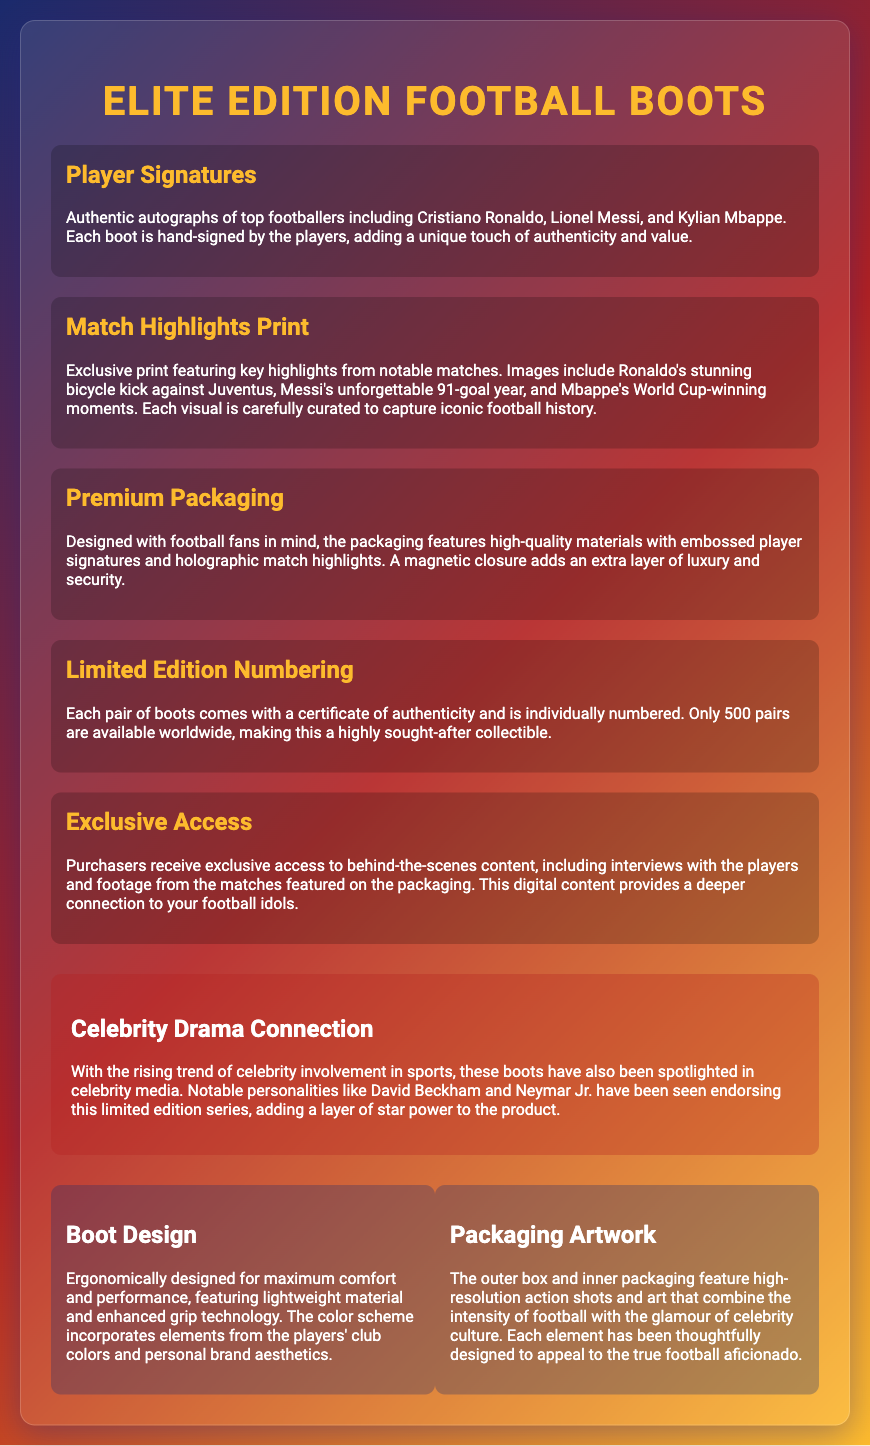What players' signatures are included? The document lists Cristiano Ronaldo, Lionel Messi, and Kylian Mbappe as signed players.
Answer: Cristiano Ronaldo, Lionel Messi, Kylian Mbappe How many pairs of boots are available worldwide? The document states that only 500 pairs of boots are available worldwide.
Answer: 500 What feature highlights a memorable year for Messi? The "Match Highlights Print" discusses Messi's unforgettable 91-goal year.
Answer: 91-goal year What type of technology is mentioned for boot performance? The document mentions "enhanced grip technology" as part of the boot design.
Answer: Enhanced grip technology What connects this product to celebrity culture? The inclusion of endorsements by notable personalities like David Beckham and Neymar Jr. highlights the celebrity connection.
Answer: Celebrity endorsements What kind of closure does the packaging have? The packaging features a "magnetic closure" as described in the premium packaging section.
Answer: Magnetic closure What is provided with each pair of boots? The document states that each pair comes with a "certificate of authenticity."
Answer: Certificate of authenticity What differentiates this packaging from standard packaging? The packaging features "high-quality materials with embossed player signatures and holographic match highlights."
Answer: High-quality materials and embossed signatures What are the design aspects of the boots focused on? The boot design emphasizes "maximum comfort and performance" with specific ergonomic considerations.
Answer: Maximum comfort and performance 